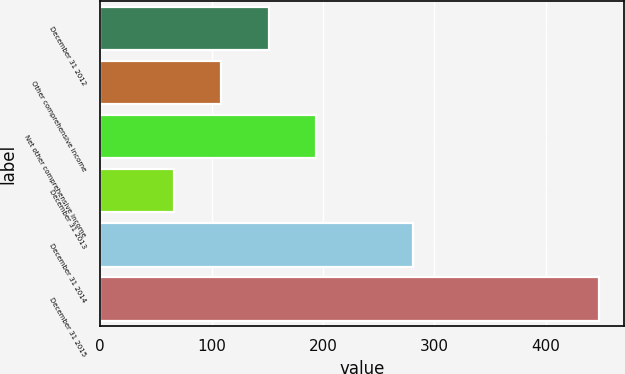Convert chart to OTSL. <chart><loc_0><loc_0><loc_500><loc_500><bar_chart><fcel>December 31 2012<fcel>Other comprehensive income<fcel>Net other comprehensive income<fcel>December 31 2013<fcel>December 31 2014<fcel>December 31 2015<nl><fcel>151.2<fcel>108.8<fcel>193.6<fcel>66.4<fcel>280.4<fcel>448<nl></chart> 